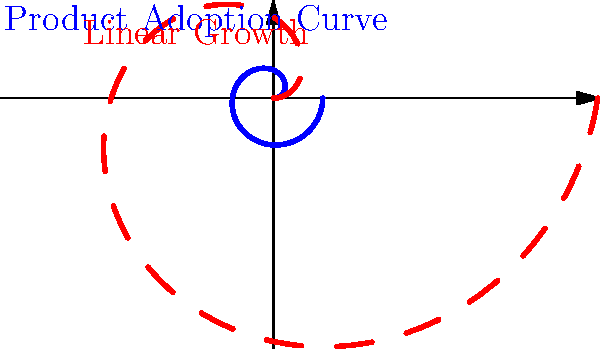As a product designer, you're analyzing the adoption curve of your sustainable product. The blue curve in the polar plot represents the actual adoption rate, while the red dashed line shows linear growth. If $r = 1 - e^{-0.5\theta}$ describes the adoption curve, where $r$ is the radius and $\theta$ is the angle, at what angle $\theta$ (in radians) does the adoption rate reach 50% of its maximum potential? To solve this problem, we need to follow these steps:

1. Understand the given equation: $r = 1 - e^{-0.5\theta}$
   This equation represents the adoption rate in polar coordinates.

2. Determine the maximum potential:
   As $\theta$ approaches infinity, $e^{-0.5\theta}$ approaches 0, so the maximum $r$ is 1.

3. Calculate 50% of the maximum potential:
   50% of 1 is 0.5

4. Set up the equation for 50% adoption:
   $0.5 = 1 - e^{-0.5\theta}$

5. Solve for $\theta$:
   $e^{-0.5\theta} = 0.5$
   $-0.5\theta = \ln(0.5)$
   $\theta = -2\ln(0.5)$
   $\theta = 2\ln(2)$

6. Calculate the final value:
   $\theta = 2 \times 0.693147... \approx 1.386$

Therefore, the adoption rate reaches 50% of its maximum potential when $\theta \approx 1.386$ radians.
Answer: $2\ln(2)$ radians 